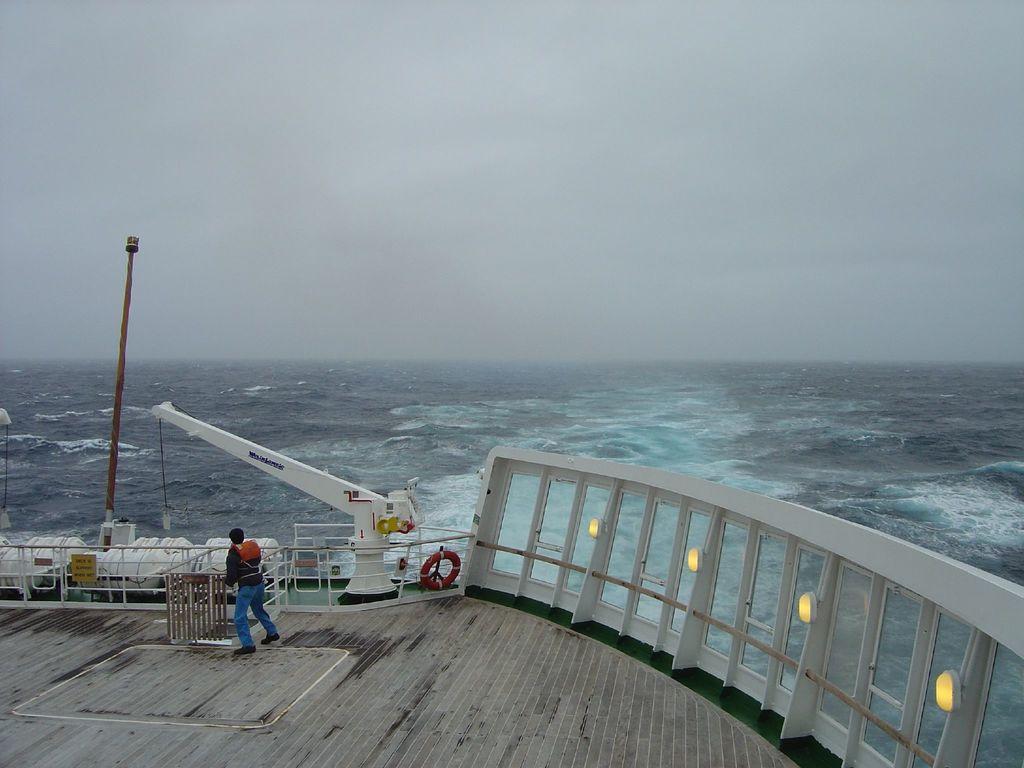Could you give a brief overview of what you see in this image? This is an outside view. At the bottom there is a person standing on the ship. On the right side there is a railing. On the left side there are two objects placed on the ship and also there is a pole. In the background there is an Ocean. At the top of the image I can see the sky. 